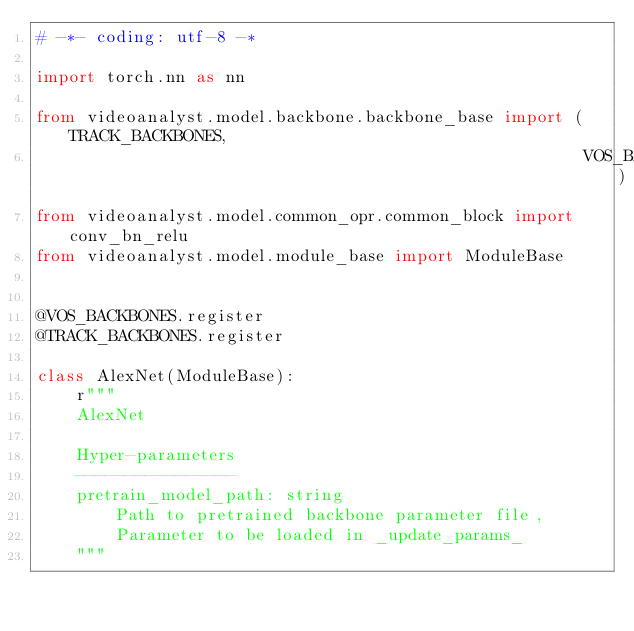Convert code to text. <code><loc_0><loc_0><loc_500><loc_500><_Python_># -*- coding: utf-8 -*

import torch.nn as nn

from videoanalyst.model.backbone.backbone_base import (TRACK_BACKBONES,
                                                       VOS_BACKBONES)
from videoanalyst.model.common_opr.common_block import conv_bn_relu
from videoanalyst.model.module_base import ModuleBase


@VOS_BACKBONES.register
@TRACK_BACKBONES.register

class AlexNet(ModuleBase):
    r"""
    AlexNet

    Hyper-parameters
    ----------------
    pretrain_model_path: string
        Path to pretrained backbone parameter file,
        Parameter to be loaded in _update_params_
    """</code> 